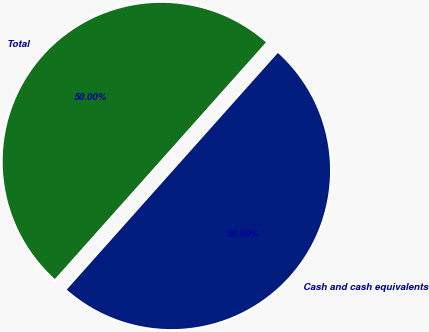Convert chart. <chart><loc_0><loc_0><loc_500><loc_500><pie_chart><fcel>Cash and cash equivalents<fcel>Total<nl><fcel>50.0%<fcel>50.0%<nl></chart> 